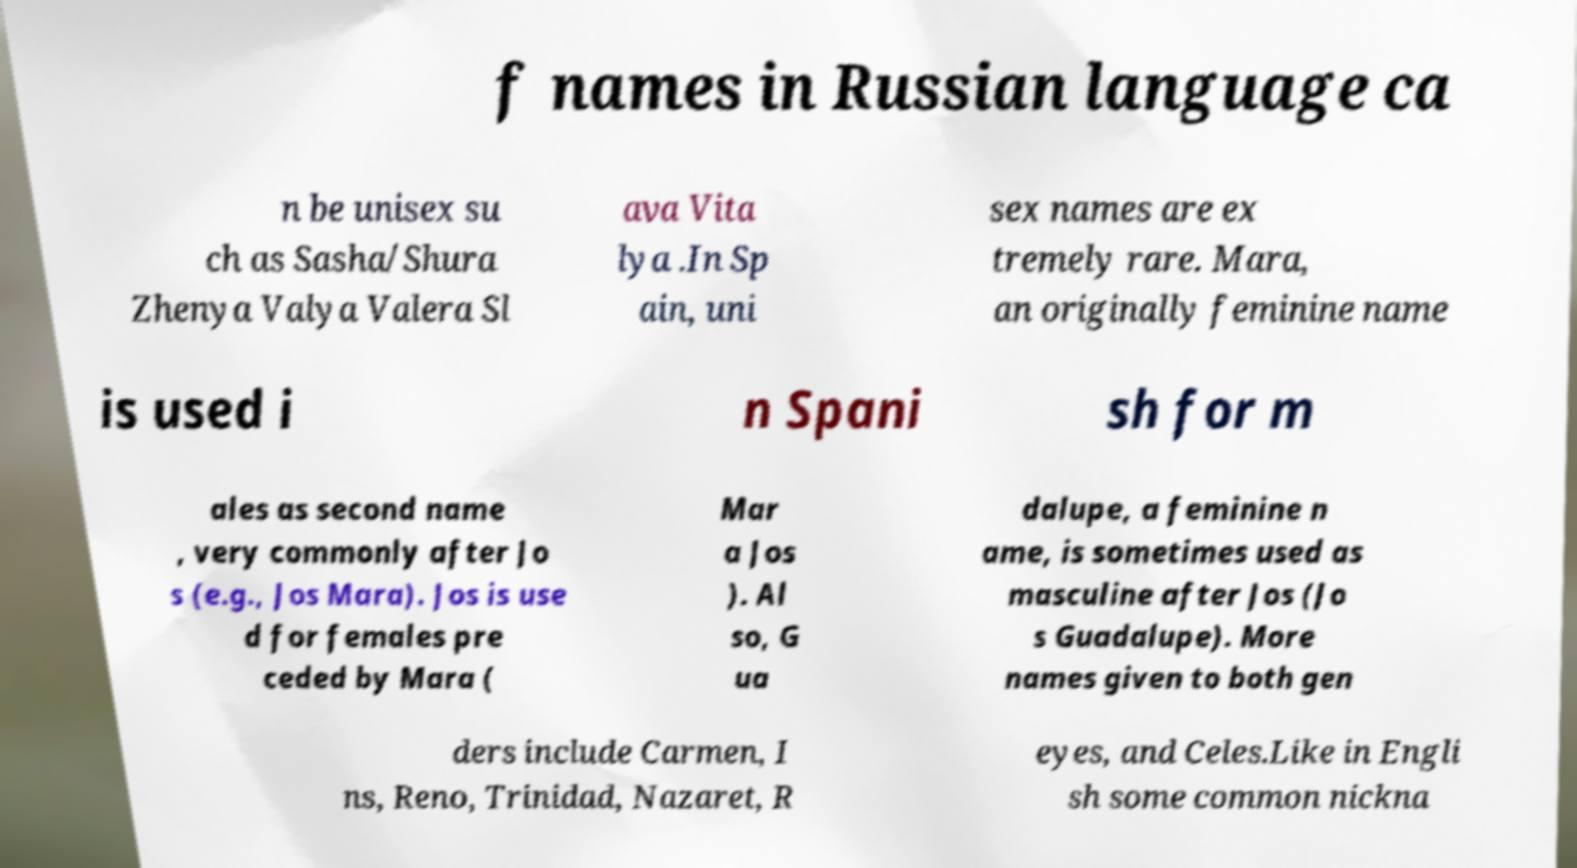For documentation purposes, I need the text within this image transcribed. Could you provide that? f names in Russian language ca n be unisex su ch as Sasha/Shura Zhenya Valya Valera Sl ava Vita lya .In Sp ain, uni sex names are ex tremely rare. Mara, an originally feminine name is used i n Spani sh for m ales as second name , very commonly after Jo s (e.g., Jos Mara). Jos is use d for females pre ceded by Mara ( Mar a Jos ). Al so, G ua dalupe, a feminine n ame, is sometimes used as masculine after Jos (Jo s Guadalupe). More names given to both gen ders include Carmen, I ns, Reno, Trinidad, Nazaret, R eyes, and Celes.Like in Engli sh some common nickna 